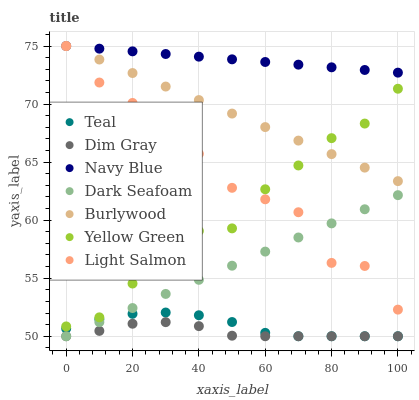Does Dim Gray have the minimum area under the curve?
Answer yes or no. Yes. Does Navy Blue have the maximum area under the curve?
Answer yes or no. Yes. Does Yellow Green have the minimum area under the curve?
Answer yes or no. No. Does Yellow Green have the maximum area under the curve?
Answer yes or no. No. Is Dark Seafoam the smoothest?
Answer yes or no. Yes. Is Light Salmon the roughest?
Answer yes or no. Yes. Is Dim Gray the smoothest?
Answer yes or no. No. Is Dim Gray the roughest?
Answer yes or no. No. Does Dim Gray have the lowest value?
Answer yes or no. Yes. Does Yellow Green have the lowest value?
Answer yes or no. No. Does Navy Blue have the highest value?
Answer yes or no. Yes. Does Yellow Green have the highest value?
Answer yes or no. No. Is Dark Seafoam less than Burlywood?
Answer yes or no. Yes. Is Light Salmon greater than Teal?
Answer yes or no. Yes. Does Burlywood intersect Yellow Green?
Answer yes or no. Yes. Is Burlywood less than Yellow Green?
Answer yes or no. No. Is Burlywood greater than Yellow Green?
Answer yes or no. No. Does Dark Seafoam intersect Burlywood?
Answer yes or no. No. 